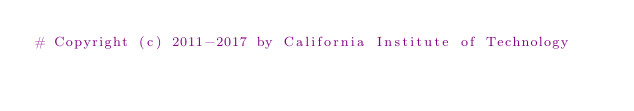<code> <loc_0><loc_0><loc_500><loc_500><_Python_># Copyright (c) 2011-2017 by California Institute of Technology</code> 